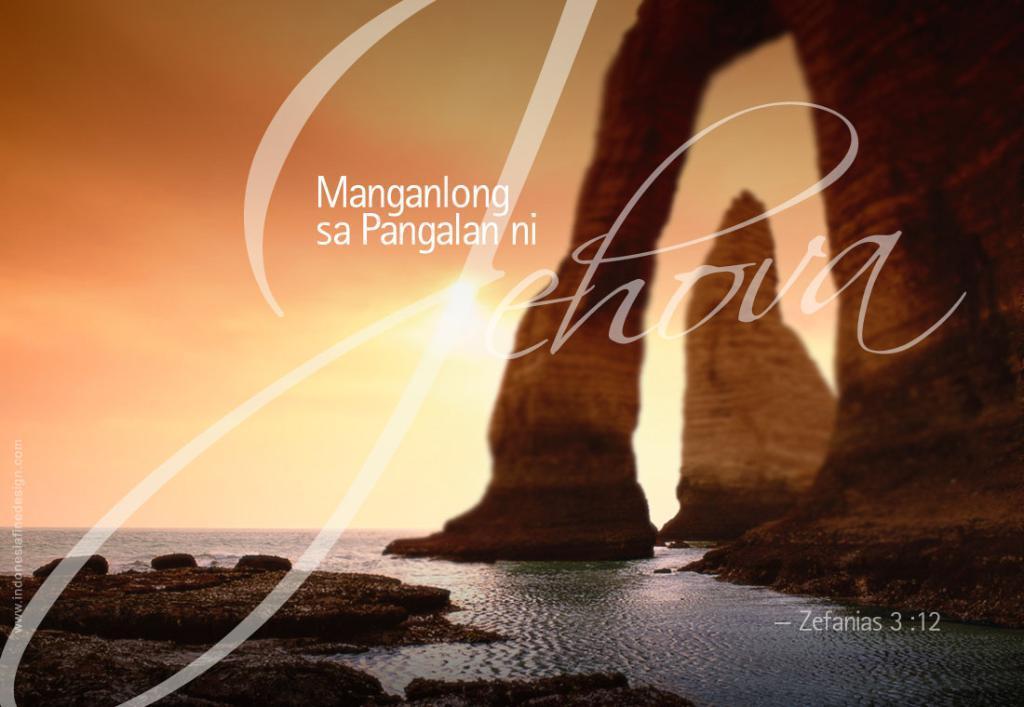Could you give a brief overview of what you see in this image? In this picture I can see the water at the bottom, on the right side those look like the stones, in the middle I can see some text, I can see the watermarks on either side of this image. At the top there is the sky. 